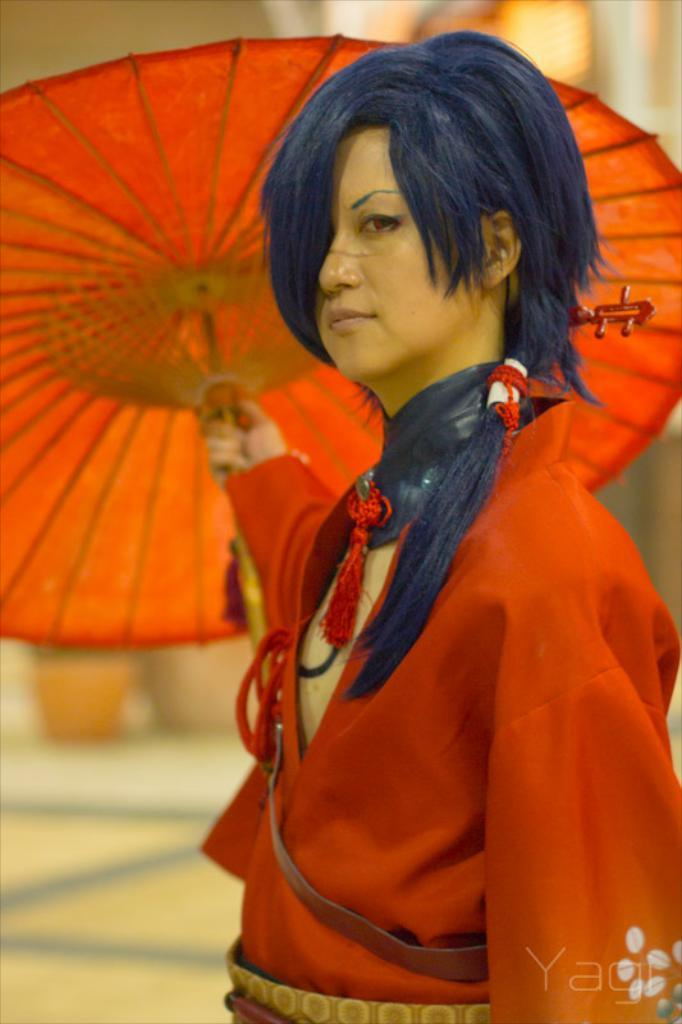Who is the main subject in the image? There is a woman in the center of the image. What is the woman holding in the image? The woman is holding an umbrella. Can you see a dog interacting with the woman and her umbrella in the image? There is no dog present in the image. Is there a cobweb visible on the woman or her umbrella in the image? There is no cobweb visible on the woman or her umbrella in the image. 